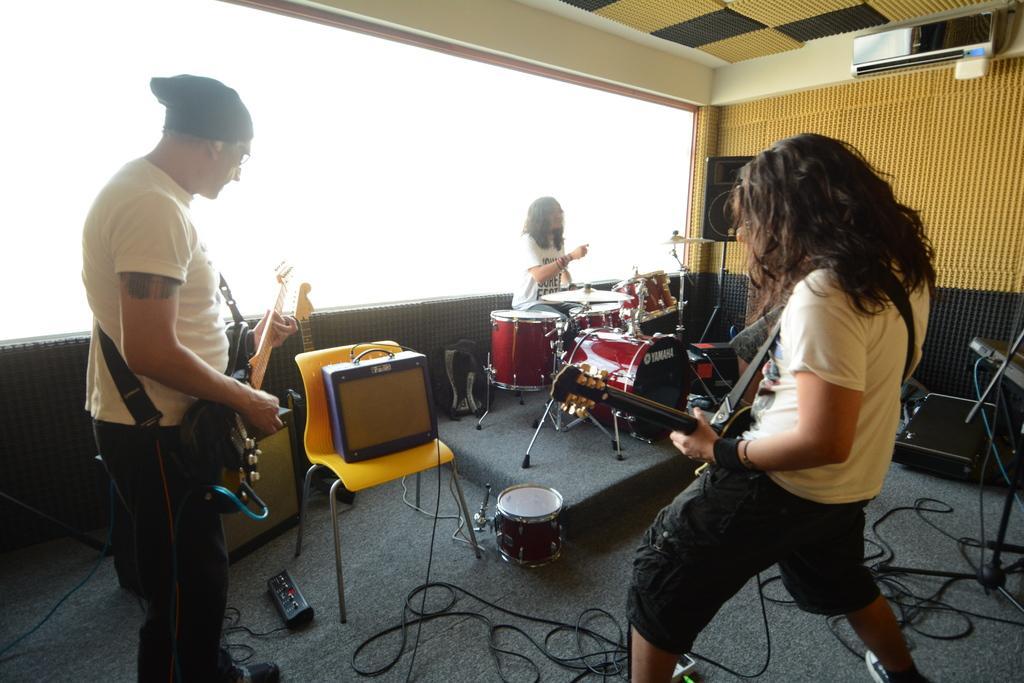In one or two sentences, can you explain what this image depicts? In this image, there is a floor which is in black color, There are some people standing and holding some music instruments and in the right side background there is a man sitting and he is playing the music drums. 